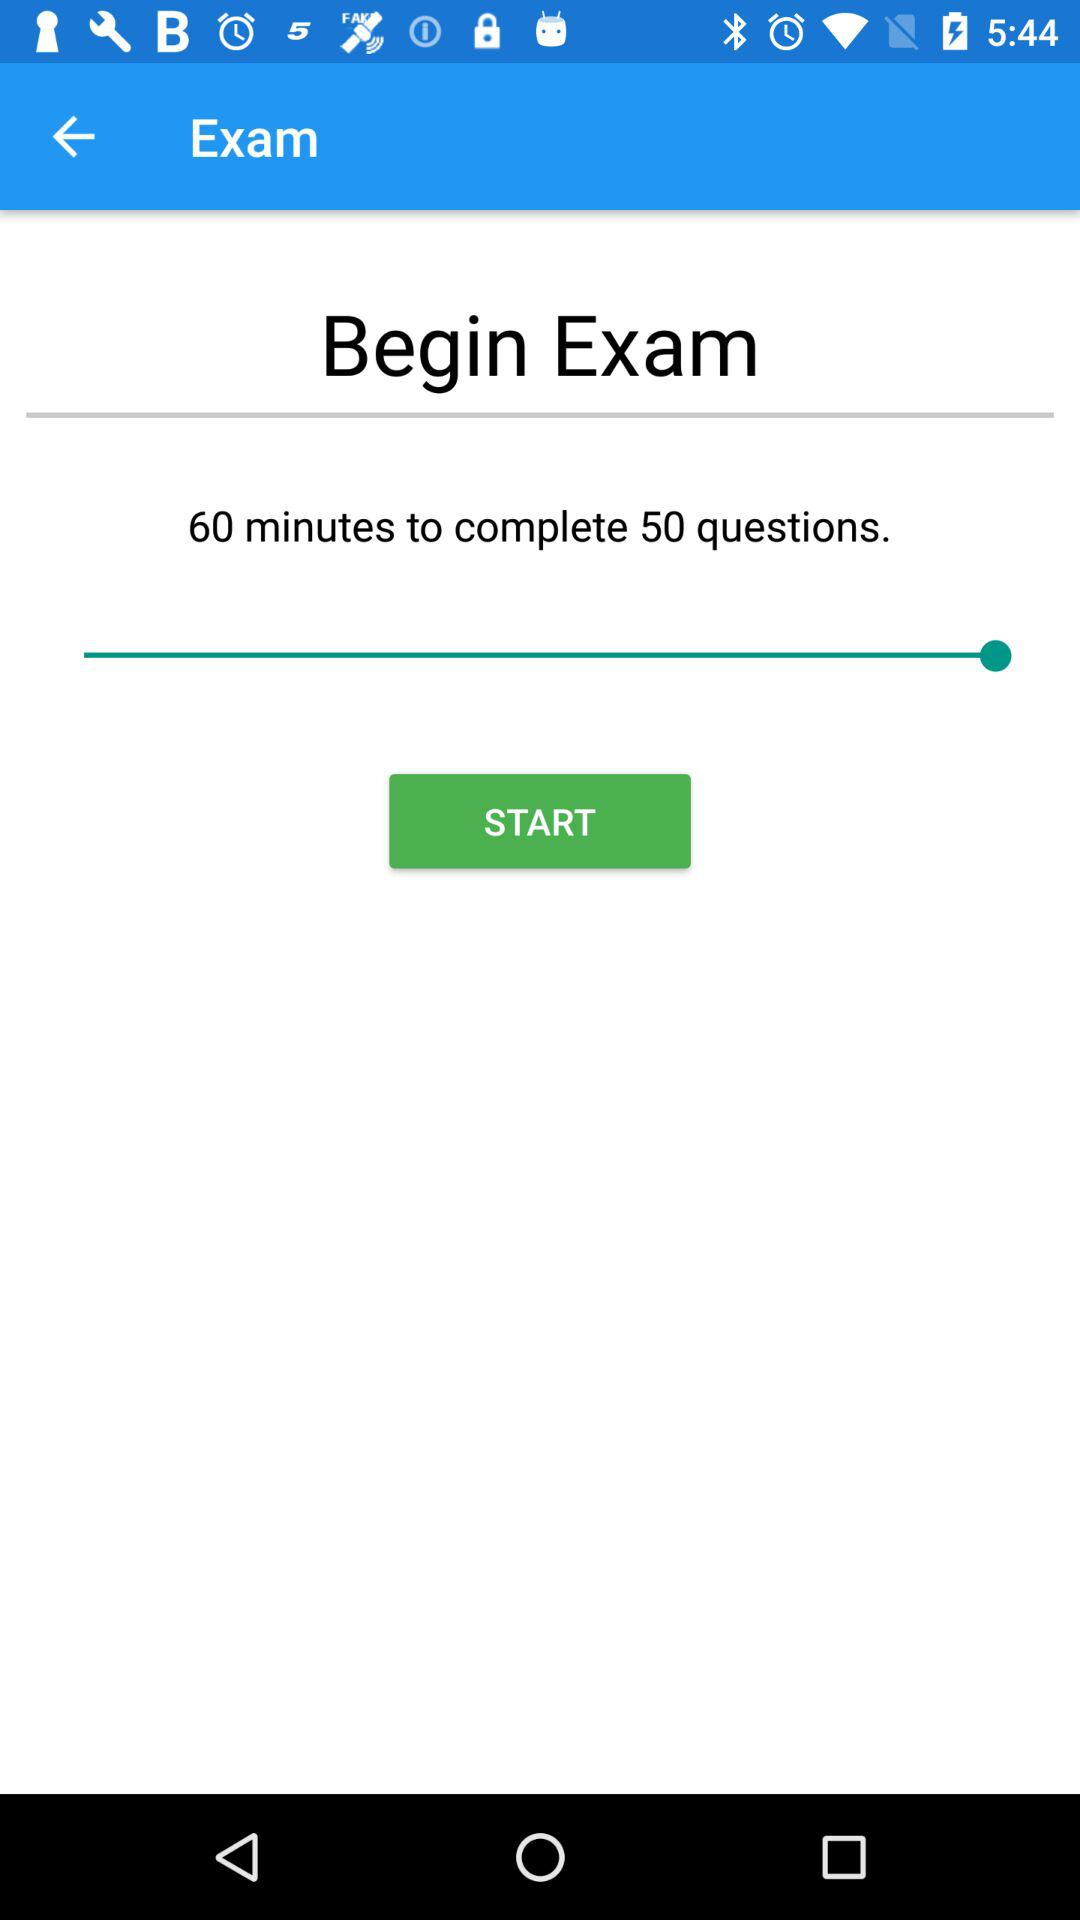How long will it take to finish 50 questions? It will take 60 minutes to finish 50 questions. 